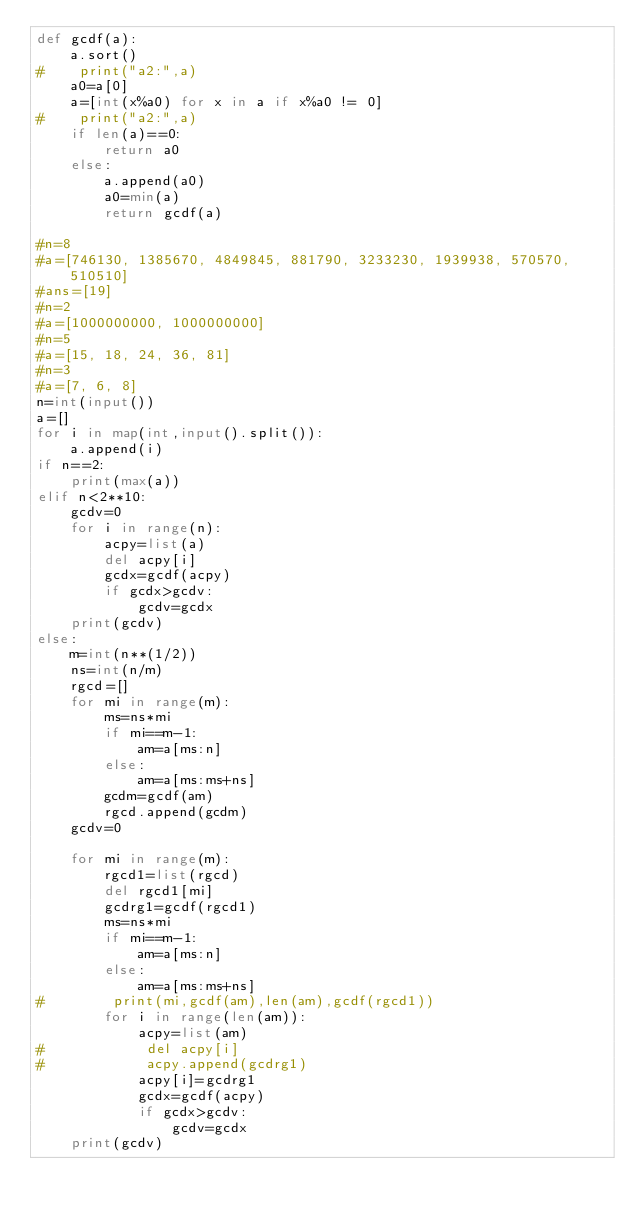<code> <loc_0><loc_0><loc_500><loc_500><_Python_>def gcdf(a):
    a.sort()
#    print("a2:",a)
    a0=a[0]
    a=[int(x%a0) for x in a if x%a0 != 0]
#    print("a2:",a)
    if len(a)==0:
        return a0
    else:
        a.append(a0)
        a0=min(a)
        return gcdf(a) 

#n=8
#a=[746130, 1385670, 4849845, 881790, 3233230, 1939938, 570570, 510510]
#ans=[19]
#n=2
#a=[1000000000, 1000000000]
#n=5
#a=[15, 18, 24, 36, 81]
#n=3
#a=[7, 6, 8]
n=int(input())
a=[]
for i in map(int,input().split()):
    a.append(i)
if n==2:
    print(max(a))
elif n<2**10:
    gcdv=0
    for i in range(n):
        acpy=list(a)
        del acpy[i]
        gcdx=gcdf(acpy)
        if gcdx>gcdv:
            gcdv=gcdx
    print(gcdv)
else:
    m=int(n**(1/2))
    ns=int(n/m)
    rgcd=[]
    for mi in range(m):
        ms=ns*mi
        if mi==m-1:
            am=a[ms:n]
        else:
            am=a[ms:ms+ns]
        gcdm=gcdf(am)
        rgcd.append(gcdm)
    gcdv=0

    for mi in range(m):
        rgcd1=list(rgcd)
        del rgcd1[mi]
        gcdrg1=gcdf(rgcd1)
        ms=ns*mi
        if mi==m-1:
            am=a[ms:n]
        else:
            am=a[ms:ms+ns]
#        print(mi,gcdf(am),len(am),gcdf(rgcd1))
        for i in range(len(am)):
            acpy=list(am)
#            del acpy[i]
#            acpy.append(gcdrg1)
            acpy[i]=gcdrg1
            gcdx=gcdf(acpy)
            if gcdx>gcdv:
                gcdv=gcdx
    print(gcdv)
</code> 